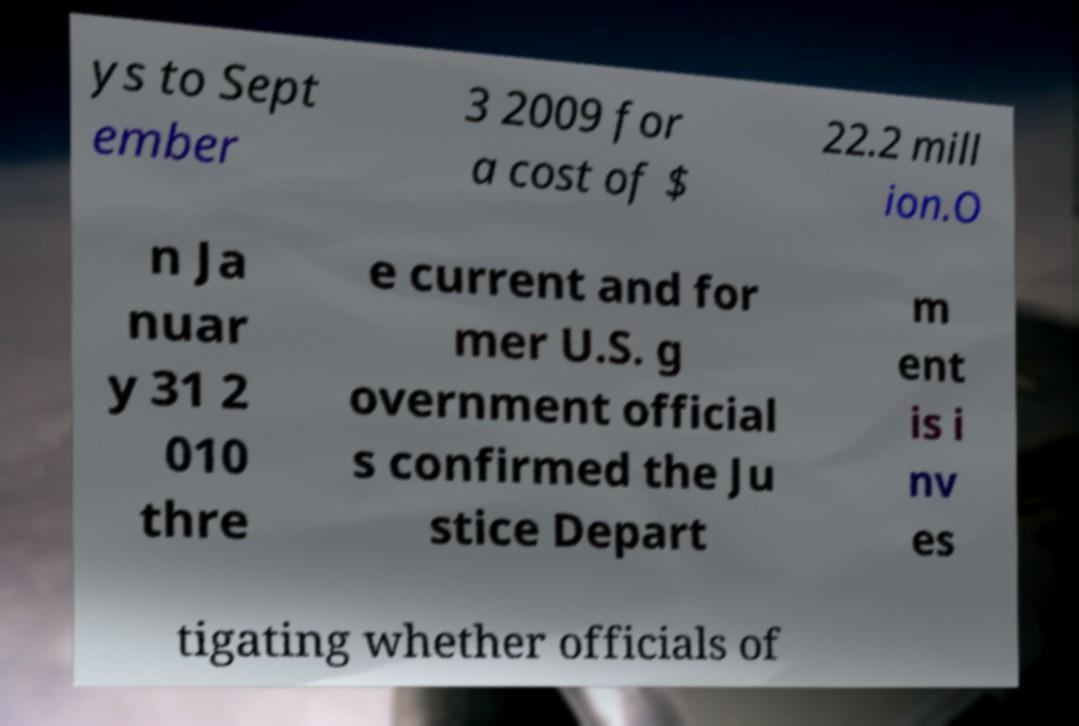Please read and relay the text visible in this image. What does it say? ys to Sept ember 3 2009 for a cost of $ 22.2 mill ion.O n Ja nuar y 31 2 010 thre e current and for mer U.S. g overnment official s confirmed the Ju stice Depart m ent is i nv es tigating whether officials of 